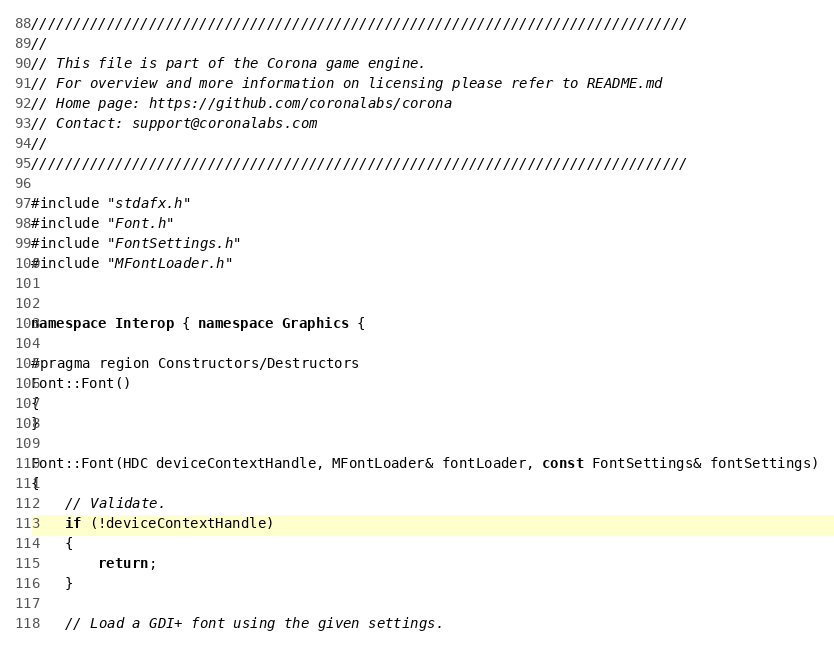<code> <loc_0><loc_0><loc_500><loc_500><_C++_>//////////////////////////////////////////////////////////////////////////////
//
// This file is part of the Corona game engine.
// For overview and more information on licensing please refer to README.md 
// Home page: https://github.com/coronalabs/corona
// Contact: support@coronalabs.com
//
//////////////////////////////////////////////////////////////////////////////

#include "stdafx.h"
#include "Font.h"
#include "FontSettings.h"
#include "MFontLoader.h"


namespace Interop { namespace Graphics {

#pragma region Constructors/Destructors
Font::Font()
{
}

Font::Font(HDC deviceContextHandle, MFontLoader& fontLoader, const FontSettings& fontSettings)
{
	// Validate.
	if (!deviceContextHandle)
	{
		return;
	}

	// Load a GDI+ font using the given settings.</code> 